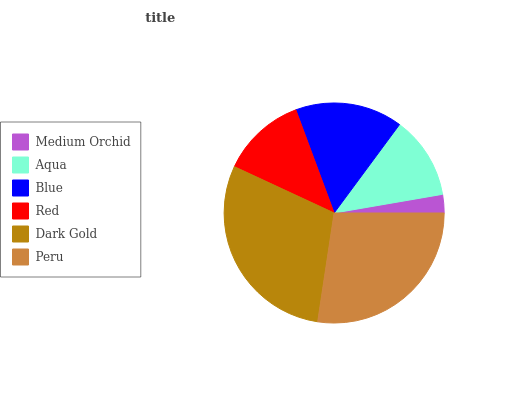Is Medium Orchid the minimum?
Answer yes or no. Yes. Is Dark Gold the maximum?
Answer yes or no. Yes. Is Aqua the minimum?
Answer yes or no. No. Is Aqua the maximum?
Answer yes or no. No. Is Aqua greater than Medium Orchid?
Answer yes or no. Yes. Is Medium Orchid less than Aqua?
Answer yes or no. Yes. Is Medium Orchid greater than Aqua?
Answer yes or no. No. Is Aqua less than Medium Orchid?
Answer yes or no. No. Is Blue the high median?
Answer yes or no. Yes. Is Red the low median?
Answer yes or no. Yes. Is Dark Gold the high median?
Answer yes or no. No. Is Blue the low median?
Answer yes or no. No. 